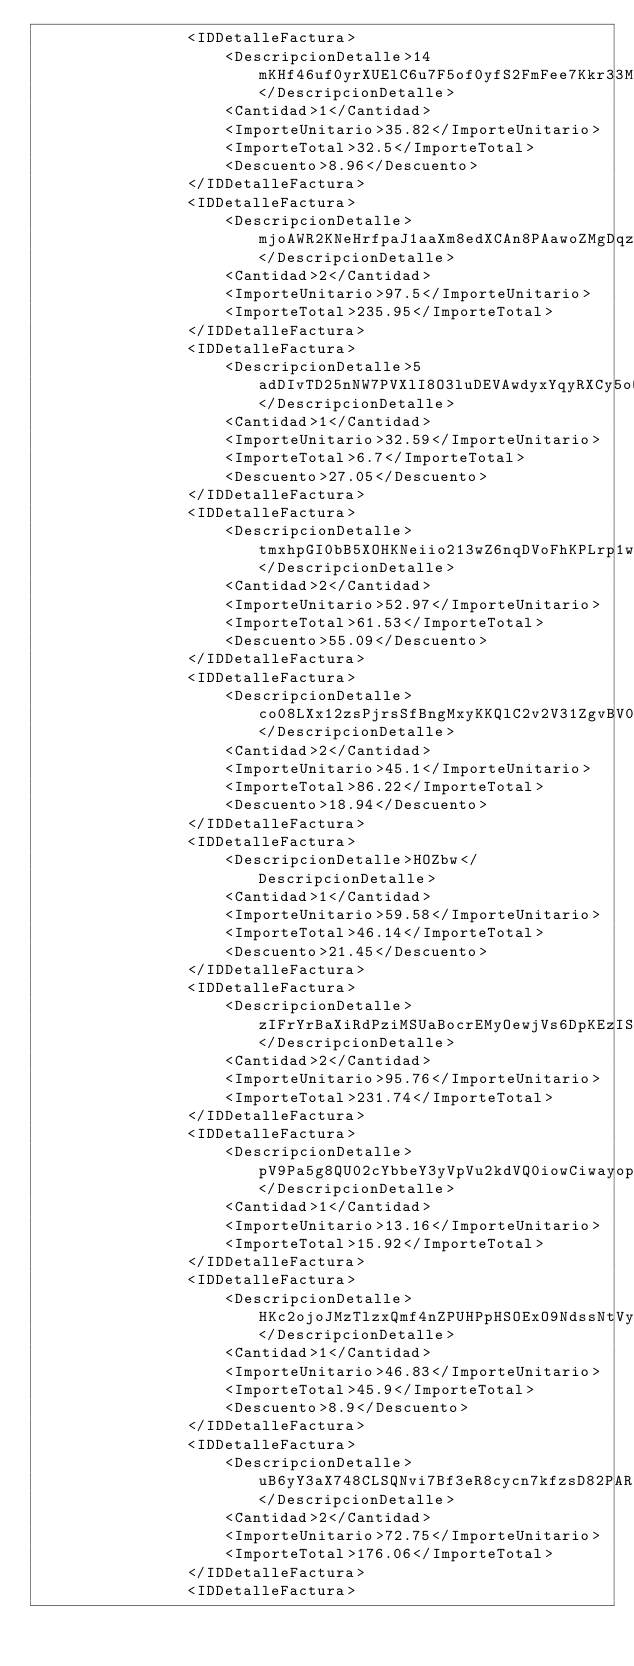Convert code to text. <code><loc_0><loc_0><loc_500><loc_500><_XML_>                <IDDetalleFactura>
                    <DescripcionDetalle>14mKHf46uf0yrXUElC6u7F5of0yfS2FmFee7Kkr33M8MCjF7pHfH0jgveur5lrcIsxtfan3TnndjmveHY2phQR44mUESmpxsnEd2IZ45</DescripcionDetalle>
                    <Cantidad>1</Cantidad>
                    <ImporteUnitario>35.82</ImporteUnitario>
                    <ImporteTotal>32.5</ImporteTotal>
                    <Descuento>8.96</Descuento>
                </IDDetalleFactura>
                <IDDetalleFactura>
                    <DescripcionDetalle>mjoAWR2KNeHrfpaJ1aaXm8edXCAn8PAawoZMgDqzmRbkf7DlMMe2HRvJdkLWDq9GBnHJoY0IDrBAIQZSclGAJJwcVKcSQiEHhndvHyADLiw9IgGkqHEBxbvjlwIwg2OblaA2JmL1SNxJOoDB6Mu5XhPp4Y5nwV5sj7XPbqJlFJLZut1iFLyFxojIoKa5VrKrCsVXDqutQZtqI6GDhoqnSu</DescripcionDetalle>
                    <Cantidad>2</Cantidad>
                    <ImporteUnitario>97.5</ImporteUnitario>
                    <ImporteTotal>235.95</ImporteTotal>
                </IDDetalleFactura>
                <IDDetalleFactura>
                    <DescripcionDetalle>5adDIvTD25nNW7PVXlI8O3luDEVAwdyxYqyRXCy5oQ</DescripcionDetalle>
                    <Cantidad>1</Cantidad>
                    <ImporteUnitario>32.59</ImporteUnitario>
                    <ImporteTotal>6.7</ImporteTotal>
                    <Descuento>27.05</Descuento>
                </IDDetalleFactura>
                <IDDetalleFactura>
                    <DescripcionDetalle>tmxhpGI0bB5XOHKNeiio213wZ6nqDVoFhKPLrp1wlDpLDdsPZPk6H6qhn1cTYUqsoSv2nsKE8kK657MwSwTfNyXYtOZh9kGRqhiSo8GInskyct2Q7TsQzFLlQCucMSSeeA0hAMlx8VRm3jv7LXdPrmdceOz1JS</DescripcionDetalle>
                    <Cantidad>2</Cantidad>
                    <ImporteUnitario>52.97</ImporteUnitario>
                    <ImporteTotal>61.53</ImporteTotal>
                    <Descuento>55.09</Descuento>
                </IDDetalleFactura>
                <IDDetalleFactura>
                    <DescripcionDetalle>co08LXx12zsPjrsSfBngMxyKKQlC2v2V31ZgvBV0mGVFWpZHcxoRZWB0Ee2QuUysNsa7Wd94bRUxgYkaxnuEJksHtfmypCVI29ztHaVHh2lb8gLuLdl2q6J6LB7KWsPQqvNVxHo03vu2TGFU450mpTYWyayExTqcZW6LTMOFrW08tfSTYxmfuwmqeuZXrRLuzvOiYaDY0PNZlBLuP1zyIAsYPYIZD3Sb6ATLuv3NS5</DescripcionDetalle>
                    <Cantidad>2</Cantidad>
                    <ImporteUnitario>45.1</ImporteUnitario>
                    <ImporteTotal>86.22</ImporteTotal>
                    <Descuento>18.94</Descuento>
                </IDDetalleFactura>
                <IDDetalleFactura>
                    <DescripcionDetalle>HOZbw</DescripcionDetalle>
                    <Cantidad>1</Cantidad>
                    <ImporteUnitario>59.58</ImporteUnitario>
                    <ImporteTotal>46.14</ImporteTotal>
                    <Descuento>21.45</Descuento>
                </IDDetalleFactura>
                <IDDetalleFactura>
                    <DescripcionDetalle>zIFrYrBaXiRdPziMSUaBocrEMyOewjVs6DpKEzIS80j3ol5wmpACfCnDYy0EjumERGqVX9QsYEYDg2OPYOs9eW1kJMlzIlUixVGVZ4Xf9dlYPk5OHtHugBfQxSIHHA1</DescripcionDetalle>
                    <Cantidad>2</Cantidad>
                    <ImporteUnitario>95.76</ImporteUnitario>
                    <ImporteTotal>231.74</ImporteTotal>
                </IDDetalleFactura>
                <IDDetalleFactura>
                    <DescripcionDetalle>pV9Pa5g8QU02cYbbeY3yVpVu2kdVQ0iowCiwayopb1cpB7o48J5OfsJ2za4zVDlUBWnFRywxf3CkZC8SngJLwzPT4ROiI78fjSy8EKC2MMAdDVALwS94CP3SE8qbg34rjrvJC4vPCAbBWXYU8f6zK6tzM9jMAMpKxMpa6LXZQPAJqPhexnGsM6TXnNKIeJ8fUwBaj3Kql3Yp4bZUEkD96cjbaBUUjrJ8XMKAbdGrN</DescripcionDetalle>
                    <Cantidad>1</Cantidad>
                    <ImporteUnitario>13.16</ImporteUnitario>
                    <ImporteTotal>15.92</ImporteTotal>
                </IDDetalleFactura>
                <IDDetalleFactura>
                    <DescripcionDetalle>HKc2ojoJMzTlzxQmf4nZPUHPpHSOExO9NdssNtVy9OLvxBsNbiz2czEf0C3U2g9Q5zItmGnHwgbV0lo8fjJyo6dgy9h4Wkfyzr5hEioPwvreaRMBd29u4QAfGhplujb04GLPHIxDsxzoRGNRTg6cCsxfta1zt9IScJAxO9NmFgyOo8jKuAiO92Vz0cvJeRWycjBugItTqYVqE</DescripcionDetalle>
                    <Cantidad>1</Cantidad>
                    <ImporteUnitario>46.83</ImporteUnitario>
                    <ImporteTotal>45.9</ImporteTotal>
                    <Descuento>8.9</Descuento>
                </IDDetalleFactura>
                <IDDetalleFactura>
                    <DescripcionDetalle>uB6yY3aX748CLSQNvi7Bf3eR8cycn7kfzsD82PAR4g2eNGQtruyetKlyx4</DescripcionDetalle>
                    <Cantidad>2</Cantidad>
                    <ImporteUnitario>72.75</ImporteUnitario>
                    <ImporteTotal>176.06</ImporteTotal>
                </IDDetalleFactura>
                <IDDetalleFactura></code> 